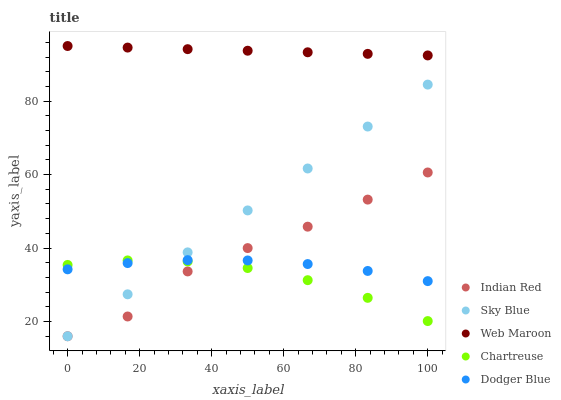Does Chartreuse have the minimum area under the curve?
Answer yes or no. Yes. Does Web Maroon have the maximum area under the curve?
Answer yes or no. Yes. Does Web Maroon have the minimum area under the curve?
Answer yes or no. No. Does Chartreuse have the maximum area under the curve?
Answer yes or no. No. Is Web Maroon the smoothest?
Answer yes or no. Yes. Is Indian Red the roughest?
Answer yes or no. Yes. Is Chartreuse the smoothest?
Answer yes or no. No. Is Chartreuse the roughest?
Answer yes or no. No. Does Sky Blue have the lowest value?
Answer yes or no. Yes. Does Chartreuse have the lowest value?
Answer yes or no. No. Does Web Maroon have the highest value?
Answer yes or no. Yes. Does Chartreuse have the highest value?
Answer yes or no. No. Is Dodger Blue less than Web Maroon?
Answer yes or no. Yes. Is Web Maroon greater than Indian Red?
Answer yes or no. Yes. Does Dodger Blue intersect Indian Red?
Answer yes or no. Yes. Is Dodger Blue less than Indian Red?
Answer yes or no. No. Is Dodger Blue greater than Indian Red?
Answer yes or no. No. Does Dodger Blue intersect Web Maroon?
Answer yes or no. No. 